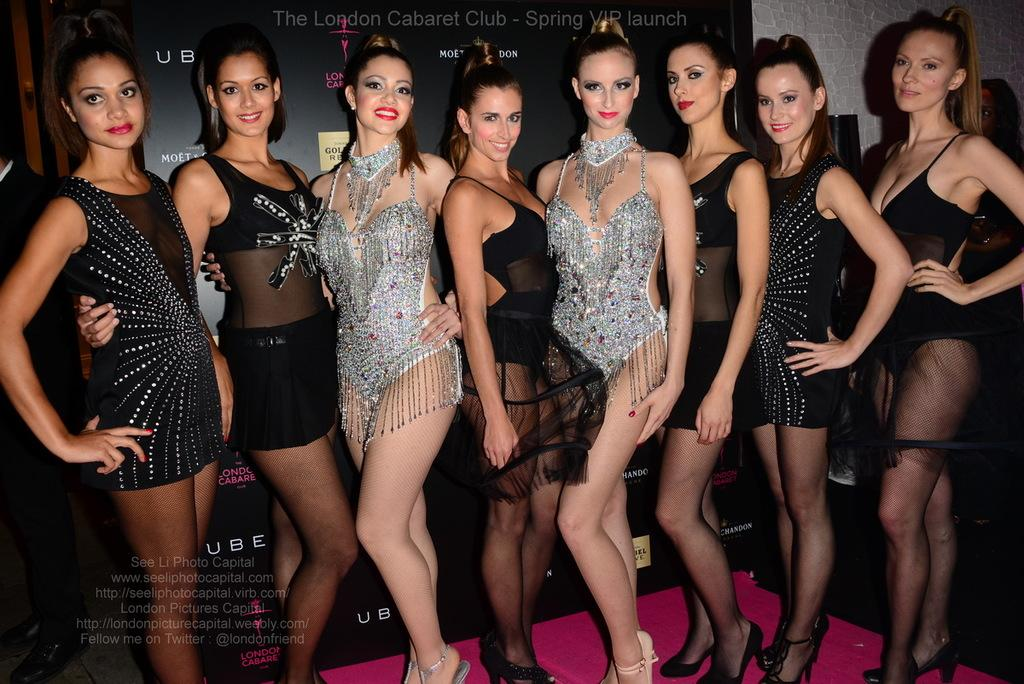What are the ladies in the image doing? The ladies are standing in the center of the image. What can be seen in the background of the image? There is a banner and a wall in the background of the image. What is at the bottom of the image? There is a carpet at the bottom of the image. How does the jellyfish help the ladies in the image? There are no jellyfish present in the image, so it cannot help the ladies. 